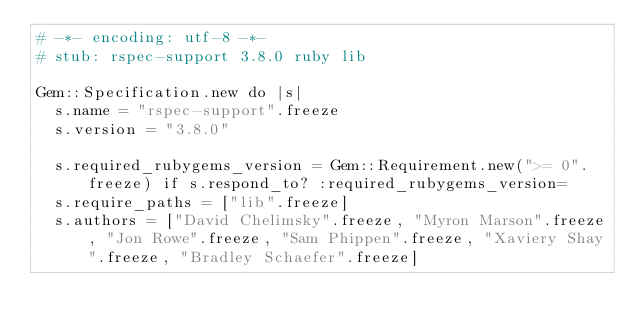Convert code to text. <code><loc_0><loc_0><loc_500><loc_500><_Ruby_># -*- encoding: utf-8 -*-
# stub: rspec-support 3.8.0 ruby lib

Gem::Specification.new do |s|
  s.name = "rspec-support".freeze
  s.version = "3.8.0"

  s.required_rubygems_version = Gem::Requirement.new(">= 0".freeze) if s.respond_to? :required_rubygems_version=
  s.require_paths = ["lib".freeze]
  s.authors = ["David Chelimsky".freeze, "Myron Marson".freeze, "Jon Rowe".freeze, "Sam Phippen".freeze, "Xaviery Shay".freeze, "Bradley Schaefer".freeze]</code> 